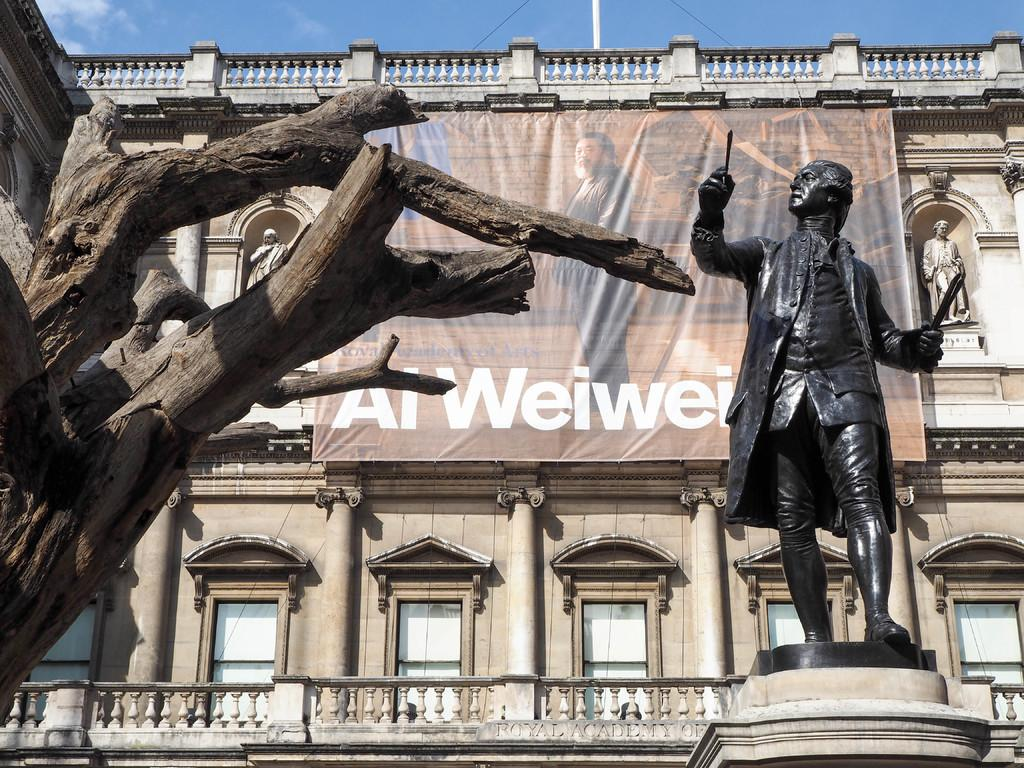<image>
Render a clear and concise summary of the photo. A large banner hanging from an old building has the word Al at the bottom. 